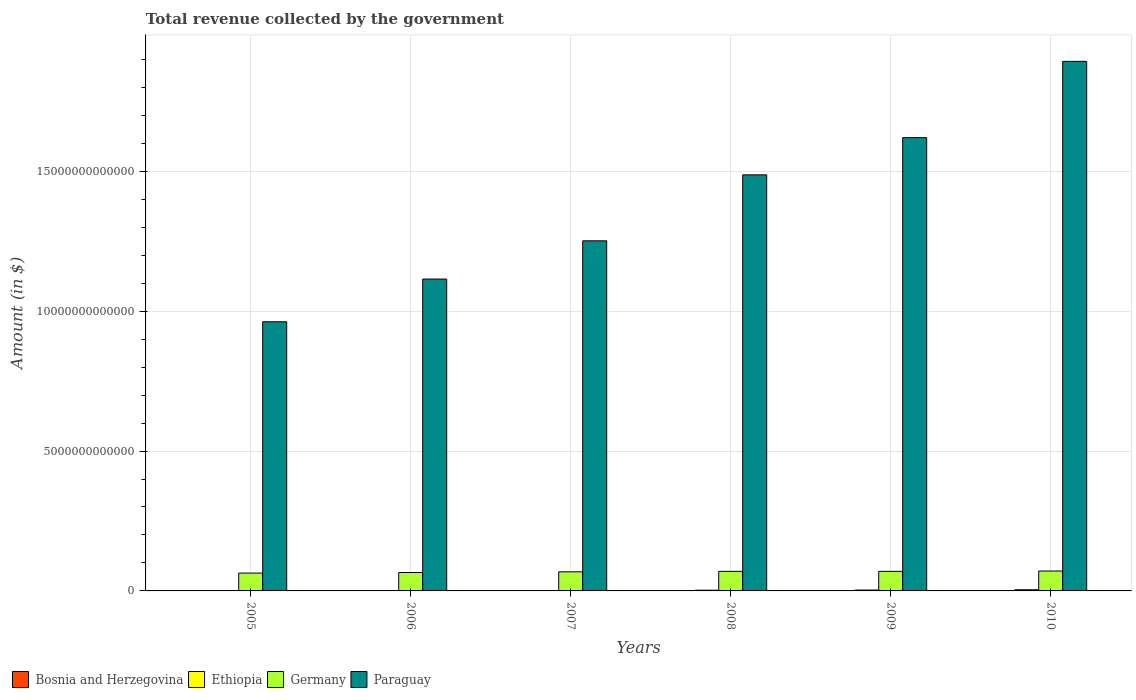How many different coloured bars are there?
Your answer should be compact. 4. Are the number of bars per tick equal to the number of legend labels?
Provide a succinct answer. Yes. How many bars are there on the 4th tick from the left?
Offer a very short reply. 4. What is the total revenue collected by the government in Ethiopia in 2008?
Your response must be concise. 2.54e+1. Across all years, what is the maximum total revenue collected by the government in Ethiopia?
Provide a succinct answer. 4.15e+1. Across all years, what is the minimum total revenue collected by the government in Paraguay?
Your answer should be compact. 9.62e+12. In which year was the total revenue collected by the government in Bosnia and Herzegovina minimum?
Provide a short and direct response. 2005. What is the total total revenue collected by the government in Ethiopia in the graph?
Offer a very short reply. 1.37e+11. What is the difference between the total revenue collected by the government in Paraguay in 2005 and that in 2009?
Keep it short and to the point. -6.58e+12. What is the difference between the total revenue collected by the government in Ethiopia in 2007 and the total revenue collected by the government in Paraguay in 2006?
Your answer should be compact. -1.11e+13. What is the average total revenue collected by the government in Paraguay per year?
Provide a short and direct response. 1.39e+13. In the year 2010, what is the difference between the total revenue collected by the government in Germany and total revenue collected by the government in Paraguay?
Make the answer very short. -1.82e+13. What is the ratio of the total revenue collected by the government in Germany in 2005 to that in 2010?
Give a very brief answer. 0.9. Is the difference between the total revenue collected by the government in Germany in 2009 and 2010 greater than the difference between the total revenue collected by the government in Paraguay in 2009 and 2010?
Provide a short and direct response. Yes. What is the difference between the highest and the second highest total revenue collected by the government in Bosnia and Herzegovina?
Give a very brief answer. 6.63e+07. What is the difference between the highest and the lowest total revenue collected by the government in Bosnia and Herzegovina?
Your response must be concise. 3.46e+09. In how many years, is the total revenue collected by the government in Paraguay greater than the average total revenue collected by the government in Paraguay taken over all years?
Provide a succinct answer. 3. Is the sum of the total revenue collected by the government in Germany in 2007 and 2010 greater than the maximum total revenue collected by the government in Paraguay across all years?
Provide a succinct answer. No. What does the 1st bar from the left in 2005 represents?
Ensure brevity in your answer.  Bosnia and Herzegovina. What does the 1st bar from the right in 2008 represents?
Make the answer very short. Paraguay. Are all the bars in the graph horizontal?
Give a very brief answer. No. How many years are there in the graph?
Your response must be concise. 6. What is the difference between two consecutive major ticks on the Y-axis?
Give a very brief answer. 5.00e+12. Are the values on the major ticks of Y-axis written in scientific E-notation?
Ensure brevity in your answer.  No. Does the graph contain any zero values?
Keep it short and to the point. No. Does the graph contain grids?
Offer a very short reply. Yes. Where does the legend appear in the graph?
Offer a very short reply. Bottom left. What is the title of the graph?
Keep it short and to the point. Total revenue collected by the government. What is the label or title of the Y-axis?
Your answer should be compact. Amount (in $). What is the Amount (in $) in Bosnia and Herzegovina in 2005?
Provide a short and direct response. 6.27e+09. What is the Amount (in $) in Ethiopia in 2005?
Your answer should be compact. 1.17e+1. What is the Amount (in $) of Germany in 2005?
Make the answer very short. 6.37e+11. What is the Amount (in $) of Paraguay in 2005?
Provide a succinct answer. 9.62e+12. What is the Amount (in $) of Bosnia and Herzegovina in 2006?
Your answer should be compact. 7.62e+09. What is the Amount (in $) of Ethiopia in 2006?
Make the answer very short. 1.18e+1. What is the Amount (in $) of Germany in 2006?
Your response must be concise. 6.58e+11. What is the Amount (in $) of Paraguay in 2006?
Give a very brief answer. 1.11e+13. What is the Amount (in $) of Bosnia and Herzegovina in 2007?
Your response must be concise. 8.71e+09. What is the Amount (in $) in Ethiopia in 2007?
Your answer should be compact. 1.43e+1. What is the Amount (in $) of Germany in 2007?
Make the answer very short. 6.83e+11. What is the Amount (in $) in Paraguay in 2007?
Offer a terse response. 1.25e+13. What is the Amount (in $) of Bosnia and Herzegovina in 2008?
Keep it short and to the point. 9.67e+09. What is the Amount (in $) in Ethiopia in 2008?
Offer a very short reply. 2.54e+1. What is the Amount (in $) of Germany in 2008?
Give a very brief answer. 6.99e+11. What is the Amount (in $) of Paraguay in 2008?
Offer a very short reply. 1.49e+13. What is the Amount (in $) of Bosnia and Herzegovina in 2009?
Ensure brevity in your answer.  9.26e+09. What is the Amount (in $) in Ethiopia in 2009?
Your response must be concise. 3.18e+1. What is the Amount (in $) of Germany in 2009?
Offer a terse response. 7.00e+11. What is the Amount (in $) in Paraguay in 2009?
Your response must be concise. 1.62e+13. What is the Amount (in $) in Bosnia and Herzegovina in 2010?
Ensure brevity in your answer.  9.73e+09. What is the Amount (in $) of Ethiopia in 2010?
Ensure brevity in your answer.  4.15e+1. What is the Amount (in $) of Germany in 2010?
Provide a succinct answer. 7.12e+11. What is the Amount (in $) of Paraguay in 2010?
Your response must be concise. 1.89e+13. Across all years, what is the maximum Amount (in $) in Bosnia and Herzegovina?
Keep it short and to the point. 9.73e+09. Across all years, what is the maximum Amount (in $) of Ethiopia?
Your response must be concise. 4.15e+1. Across all years, what is the maximum Amount (in $) of Germany?
Make the answer very short. 7.12e+11. Across all years, what is the maximum Amount (in $) of Paraguay?
Provide a succinct answer. 1.89e+13. Across all years, what is the minimum Amount (in $) of Bosnia and Herzegovina?
Keep it short and to the point. 6.27e+09. Across all years, what is the minimum Amount (in $) of Ethiopia?
Your response must be concise. 1.17e+1. Across all years, what is the minimum Amount (in $) in Germany?
Provide a short and direct response. 6.37e+11. Across all years, what is the minimum Amount (in $) in Paraguay?
Provide a short and direct response. 9.62e+12. What is the total Amount (in $) in Bosnia and Herzegovina in the graph?
Provide a succinct answer. 5.13e+1. What is the total Amount (in $) of Ethiopia in the graph?
Offer a very short reply. 1.37e+11. What is the total Amount (in $) of Germany in the graph?
Keep it short and to the point. 4.09e+12. What is the total Amount (in $) in Paraguay in the graph?
Make the answer very short. 8.33e+13. What is the difference between the Amount (in $) in Bosnia and Herzegovina in 2005 and that in 2006?
Give a very brief answer. -1.36e+09. What is the difference between the Amount (in $) of Ethiopia in 2005 and that in 2006?
Offer a terse response. -3.44e+07. What is the difference between the Amount (in $) of Germany in 2005 and that in 2006?
Give a very brief answer. -2.10e+1. What is the difference between the Amount (in $) in Paraguay in 2005 and that in 2006?
Give a very brief answer. -1.53e+12. What is the difference between the Amount (in $) of Bosnia and Herzegovina in 2005 and that in 2007?
Your answer should be compact. -2.44e+09. What is the difference between the Amount (in $) of Ethiopia in 2005 and that in 2007?
Your answer should be compact. -2.59e+09. What is the difference between the Amount (in $) of Germany in 2005 and that in 2007?
Offer a terse response. -4.54e+1. What is the difference between the Amount (in $) of Paraguay in 2005 and that in 2007?
Offer a terse response. -2.89e+12. What is the difference between the Amount (in $) of Bosnia and Herzegovina in 2005 and that in 2008?
Offer a very short reply. -3.40e+09. What is the difference between the Amount (in $) in Ethiopia in 2005 and that in 2008?
Ensure brevity in your answer.  -1.36e+1. What is the difference between the Amount (in $) of Germany in 2005 and that in 2008?
Your response must be concise. -6.20e+1. What is the difference between the Amount (in $) of Paraguay in 2005 and that in 2008?
Your answer should be very brief. -5.25e+12. What is the difference between the Amount (in $) of Bosnia and Herzegovina in 2005 and that in 2009?
Give a very brief answer. -3.00e+09. What is the difference between the Amount (in $) of Ethiopia in 2005 and that in 2009?
Your answer should be very brief. -2.00e+1. What is the difference between the Amount (in $) in Germany in 2005 and that in 2009?
Keep it short and to the point. -6.23e+1. What is the difference between the Amount (in $) of Paraguay in 2005 and that in 2009?
Provide a succinct answer. -6.58e+12. What is the difference between the Amount (in $) of Bosnia and Herzegovina in 2005 and that in 2010?
Offer a terse response. -3.46e+09. What is the difference between the Amount (in $) in Ethiopia in 2005 and that in 2010?
Make the answer very short. -2.98e+1. What is the difference between the Amount (in $) of Germany in 2005 and that in 2010?
Offer a terse response. -7.46e+1. What is the difference between the Amount (in $) in Paraguay in 2005 and that in 2010?
Make the answer very short. -9.31e+12. What is the difference between the Amount (in $) in Bosnia and Herzegovina in 2006 and that in 2007?
Ensure brevity in your answer.  -1.09e+09. What is the difference between the Amount (in $) of Ethiopia in 2006 and that in 2007?
Provide a succinct answer. -2.56e+09. What is the difference between the Amount (in $) of Germany in 2006 and that in 2007?
Keep it short and to the point. -2.44e+1. What is the difference between the Amount (in $) in Paraguay in 2006 and that in 2007?
Offer a terse response. -1.37e+12. What is the difference between the Amount (in $) in Bosnia and Herzegovina in 2006 and that in 2008?
Give a very brief answer. -2.04e+09. What is the difference between the Amount (in $) of Ethiopia in 2006 and that in 2008?
Give a very brief answer. -1.36e+1. What is the difference between the Amount (in $) of Germany in 2006 and that in 2008?
Your response must be concise. -4.10e+1. What is the difference between the Amount (in $) in Paraguay in 2006 and that in 2008?
Offer a very short reply. -3.73e+12. What is the difference between the Amount (in $) of Bosnia and Herzegovina in 2006 and that in 2009?
Your response must be concise. -1.64e+09. What is the difference between the Amount (in $) of Ethiopia in 2006 and that in 2009?
Provide a succinct answer. -2.00e+1. What is the difference between the Amount (in $) in Germany in 2006 and that in 2009?
Offer a terse response. -4.14e+1. What is the difference between the Amount (in $) in Paraguay in 2006 and that in 2009?
Your response must be concise. -5.06e+12. What is the difference between the Amount (in $) of Bosnia and Herzegovina in 2006 and that in 2010?
Keep it short and to the point. -2.11e+09. What is the difference between the Amount (in $) in Ethiopia in 2006 and that in 2010?
Your response must be concise. -2.98e+1. What is the difference between the Amount (in $) of Germany in 2006 and that in 2010?
Ensure brevity in your answer.  -5.36e+1. What is the difference between the Amount (in $) of Paraguay in 2006 and that in 2010?
Offer a very short reply. -7.78e+12. What is the difference between the Amount (in $) of Bosnia and Herzegovina in 2007 and that in 2008?
Your response must be concise. -9.56e+08. What is the difference between the Amount (in $) in Ethiopia in 2007 and that in 2008?
Your answer should be compact. -1.11e+1. What is the difference between the Amount (in $) in Germany in 2007 and that in 2008?
Keep it short and to the point. -1.66e+1. What is the difference between the Amount (in $) in Paraguay in 2007 and that in 2008?
Keep it short and to the point. -2.36e+12. What is the difference between the Amount (in $) in Bosnia and Herzegovina in 2007 and that in 2009?
Keep it short and to the point. -5.53e+08. What is the difference between the Amount (in $) of Ethiopia in 2007 and that in 2009?
Provide a succinct answer. -1.74e+1. What is the difference between the Amount (in $) in Germany in 2007 and that in 2009?
Provide a succinct answer. -1.69e+1. What is the difference between the Amount (in $) of Paraguay in 2007 and that in 2009?
Your response must be concise. -3.69e+12. What is the difference between the Amount (in $) of Bosnia and Herzegovina in 2007 and that in 2010?
Your answer should be very brief. -1.02e+09. What is the difference between the Amount (in $) of Ethiopia in 2007 and that in 2010?
Offer a terse response. -2.72e+1. What is the difference between the Amount (in $) in Germany in 2007 and that in 2010?
Make the answer very short. -2.92e+1. What is the difference between the Amount (in $) of Paraguay in 2007 and that in 2010?
Your answer should be compact. -6.41e+12. What is the difference between the Amount (in $) of Bosnia and Herzegovina in 2008 and that in 2009?
Provide a short and direct response. 4.02e+08. What is the difference between the Amount (in $) in Ethiopia in 2008 and that in 2009?
Offer a very short reply. -6.40e+09. What is the difference between the Amount (in $) of Germany in 2008 and that in 2009?
Keep it short and to the point. -3.50e+08. What is the difference between the Amount (in $) of Paraguay in 2008 and that in 2009?
Provide a succinct answer. -1.33e+12. What is the difference between the Amount (in $) of Bosnia and Herzegovina in 2008 and that in 2010?
Make the answer very short. -6.63e+07. What is the difference between the Amount (in $) of Ethiopia in 2008 and that in 2010?
Your answer should be compact. -1.61e+1. What is the difference between the Amount (in $) of Germany in 2008 and that in 2010?
Keep it short and to the point. -1.26e+1. What is the difference between the Amount (in $) in Paraguay in 2008 and that in 2010?
Your response must be concise. -4.06e+12. What is the difference between the Amount (in $) in Bosnia and Herzegovina in 2009 and that in 2010?
Your response must be concise. -4.68e+08. What is the difference between the Amount (in $) in Ethiopia in 2009 and that in 2010?
Provide a short and direct response. -9.75e+09. What is the difference between the Amount (in $) of Germany in 2009 and that in 2010?
Make the answer very short. -1.23e+1. What is the difference between the Amount (in $) in Paraguay in 2009 and that in 2010?
Offer a terse response. -2.73e+12. What is the difference between the Amount (in $) in Bosnia and Herzegovina in 2005 and the Amount (in $) in Ethiopia in 2006?
Make the answer very short. -5.50e+09. What is the difference between the Amount (in $) of Bosnia and Herzegovina in 2005 and the Amount (in $) of Germany in 2006?
Your response must be concise. -6.52e+11. What is the difference between the Amount (in $) in Bosnia and Herzegovina in 2005 and the Amount (in $) in Paraguay in 2006?
Give a very brief answer. -1.11e+13. What is the difference between the Amount (in $) of Ethiopia in 2005 and the Amount (in $) of Germany in 2006?
Offer a terse response. -6.46e+11. What is the difference between the Amount (in $) in Ethiopia in 2005 and the Amount (in $) in Paraguay in 2006?
Make the answer very short. -1.11e+13. What is the difference between the Amount (in $) of Germany in 2005 and the Amount (in $) of Paraguay in 2006?
Provide a short and direct response. -1.05e+13. What is the difference between the Amount (in $) of Bosnia and Herzegovina in 2005 and the Amount (in $) of Ethiopia in 2007?
Make the answer very short. -8.06e+09. What is the difference between the Amount (in $) in Bosnia and Herzegovina in 2005 and the Amount (in $) in Germany in 2007?
Your answer should be very brief. -6.76e+11. What is the difference between the Amount (in $) in Bosnia and Herzegovina in 2005 and the Amount (in $) in Paraguay in 2007?
Ensure brevity in your answer.  -1.25e+13. What is the difference between the Amount (in $) in Ethiopia in 2005 and the Amount (in $) in Germany in 2007?
Make the answer very short. -6.71e+11. What is the difference between the Amount (in $) of Ethiopia in 2005 and the Amount (in $) of Paraguay in 2007?
Ensure brevity in your answer.  -1.25e+13. What is the difference between the Amount (in $) in Germany in 2005 and the Amount (in $) in Paraguay in 2007?
Keep it short and to the point. -1.19e+13. What is the difference between the Amount (in $) in Bosnia and Herzegovina in 2005 and the Amount (in $) in Ethiopia in 2008?
Ensure brevity in your answer.  -1.91e+1. What is the difference between the Amount (in $) in Bosnia and Herzegovina in 2005 and the Amount (in $) in Germany in 2008?
Your answer should be very brief. -6.93e+11. What is the difference between the Amount (in $) in Bosnia and Herzegovina in 2005 and the Amount (in $) in Paraguay in 2008?
Provide a short and direct response. -1.49e+13. What is the difference between the Amount (in $) in Ethiopia in 2005 and the Amount (in $) in Germany in 2008?
Your answer should be compact. -6.88e+11. What is the difference between the Amount (in $) of Ethiopia in 2005 and the Amount (in $) of Paraguay in 2008?
Make the answer very short. -1.49e+13. What is the difference between the Amount (in $) in Germany in 2005 and the Amount (in $) in Paraguay in 2008?
Your response must be concise. -1.42e+13. What is the difference between the Amount (in $) in Bosnia and Herzegovina in 2005 and the Amount (in $) in Ethiopia in 2009?
Keep it short and to the point. -2.55e+1. What is the difference between the Amount (in $) in Bosnia and Herzegovina in 2005 and the Amount (in $) in Germany in 2009?
Give a very brief answer. -6.93e+11. What is the difference between the Amount (in $) in Bosnia and Herzegovina in 2005 and the Amount (in $) in Paraguay in 2009?
Your answer should be very brief. -1.62e+13. What is the difference between the Amount (in $) of Ethiopia in 2005 and the Amount (in $) of Germany in 2009?
Provide a short and direct response. -6.88e+11. What is the difference between the Amount (in $) in Ethiopia in 2005 and the Amount (in $) in Paraguay in 2009?
Give a very brief answer. -1.62e+13. What is the difference between the Amount (in $) in Germany in 2005 and the Amount (in $) in Paraguay in 2009?
Make the answer very short. -1.56e+13. What is the difference between the Amount (in $) in Bosnia and Herzegovina in 2005 and the Amount (in $) in Ethiopia in 2010?
Offer a very short reply. -3.53e+1. What is the difference between the Amount (in $) of Bosnia and Herzegovina in 2005 and the Amount (in $) of Germany in 2010?
Make the answer very short. -7.06e+11. What is the difference between the Amount (in $) in Bosnia and Herzegovina in 2005 and the Amount (in $) in Paraguay in 2010?
Offer a terse response. -1.89e+13. What is the difference between the Amount (in $) in Ethiopia in 2005 and the Amount (in $) in Germany in 2010?
Your answer should be very brief. -7.00e+11. What is the difference between the Amount (in $) of Ethiopia in 2005 and the Amount (in $) of Paraguay in 2010?
Make the answer very short. -1.89e+13. What is the difference between the Amount (in $) in Germany in 2005 and the Amount (in $) in Paraguay in 2010?
Provide a short and direct response. -1.83e+13. What is the difference between the Amount (in $) in Bosnia and Herzegovina in 2006 and the Amount (in $) in Ethiopia in 2007?
Provide a succinct answer. -6.70e+09. What is the difference between the Amount (in $) in Bosnia and Herzegovina in 2006 and the Amount (in $) in Germany in 2007?
Keep it short and to the point. -6.75e+11. What is the difference between the Amount (in $) in Bosnia and Herzegovina in 2006 and the Amount (in $) in Paraguay in 2007?
Ensure brevity in your answer.  -1.25e+13. What is the difference between the Amount (in $) in Ethiopia in 2006 and the Amount (in $) in Germany in 2007?
Offer a very short reply. -6.71e+11. What is the difference between the Amount (in $) of Ethiopia in 2006 and the Amount (in $) of Paraguay in 2007?
Your answer should be very brief. -1.25e+13. What is the difference between the Amount (in $) in Germany in 2006 and the Amount (in $) in Paraguay in 2007?
Give a very brief answer. -1.19e+13. What is the difference between the Amount (in $) in Bosnia and Herzegovina in 2006 and the Amount (in $) in Ethiopia in 2008?
Make the answer very short. -1.78e+1. What is the difference between the Amount (in $) of Bosnia and Herzegovina in 2006 and the Amount (in $) of Germany in 2008?
Keep it short and to the point. -6.92e+11. What is the difference between the Amount (in $) of Bosnia and Herzegovina in 2006 and the Amount (in $) of Paraguay in 2008?
Your answer should be compact. -1.49e+13. What is the difference between the Amount (in $) of Ethiopia in 2006 and the Amount (in $) of Germany in 2008?
Make the answer very short. -6.87e+11. What is the difference between the Amount (in $) in Ethiopia in 2006 and the Amount (in $) in Paraguay in 2008?
Your answer should be very brief. -1.49e+13. What is the difference between the Amount (in $) of Germany in 2006 and the Amount (in $) of Paraguay in 2008?
Keep it short and to the point. -1.42e+13. What is the difference between the Amount (in $) in Bosnia and Herzegovina in 2006 and the Amount (in $) in Ethiopia in 2009?
Provide a short and direct response. -2.42e+1. What is the difference between the Amount (in $) of Bosnia and Herzegovina in 2006 and the Amount (in $) of Germany in 2009?
Offer a very short reply. -6.92e+11. What is the difference between the Amount (in $) of Bosnia and Herzegovina in 2006 and the Amount (in $) of Paraguay in 2009?
Your answer should be very brief. -1.62e+13. What is the difference between the Amount (in $) of Ethiopia in 2006 and the Amount (in $) of Germany in 2009?
Your response must be concise. -6.88e+11. What is the difference between the Amount (in $) of Ethiopia in 2006 and the Amount (in $) of Paraguay in 2009?
Ensure brevity in your answer.  -1.62e+13. What is the difference between the Amount (in $) in Germany in 2006 and the Amount (in $) in Paraguay in 2009?
Provide a short and direct response. -1.55e+13. What is the difference between the Amount (in $) of Bosnia and Herzegovina in 2006 and the Amount (in $) of Ethiopia in 2010?
Your answer should be compact. -3.39e+1. What is the difference between the Amount (in $) of Bosnia and Herzegovina in 2006 and the Amount (in $) of Germany in 2010?
Offer a very short reply. -7.04e+11. What is the difference between the Amount (in $) of Bosnia and Herzegovina in 2006 and the Amount (in $) of Paraguay in 2010?
Keep it short and to the point. -1.89e+13. What is the difference between the Amount (in $) in Ethiopia in 2006 and the Amount (in $) in Germany in 2010?
Give a very brief answer. -7.00e+11. What is the difference between the Amount (in $) of Ethiopia in 2006 and the Amount (in $) of Paraguay in 2010?
Ensure brevity in your answer.  -1.89e+13. What is the difference between the Amount (in $) of Germany in 2006 and the Amount (in $) of Paraguay in 2010?
Provide a succinct answer. -1.83e+13. What is the difference between the Amount (in $) of Bosnia and Herzegovina in 2007 and the Amount (in $) of Ethiopia in 2008?
Your answer should be very brief. -1.67e+1. What is the difference between the Amount (in $) in Bosnia and Herzegovina in 2007 and the Amount (in $) in Germany in 2008?
Your answer should be compact. -6.91e+11. What is the difference between the Amount (in $) of Bosnia and Herzegovina in 2007 and the Amount (in $) of Paraguay in 2008?
Make the answer very short. -1.49e+13. What is the difference between the Amount (in $) of Ethiopia in 2007 and the Amount (in $) of Germany in 2008?
Provide a succinct answer. -6.85e+11. What is the difference between the Amount (in $) in Ethiopia in 2007 and the Amount (in $) in Paraguay in 2008?
Provide a short and direct response. -1.49e+13. What is the difference between the Amount (in $) in Germany in 2007 and the Amount (in $) in Paraguay in 2008?
Provide a short and direct response. -1.42e+13. What is the difference between the Amount (in $) in Bosnia and Herzegovina in 2007 and the Amount (in $) in Ethiopia in 2009?
Provide a short and direct response. -2.31e+1. What is the difference between the Amount (in $) of Bosnia and Herzegovina in 2007 and the Amount (in $) of Germany in 2009?
Ensure brevity in your answer.  -6.91e+11. What is the difference between the Amount (in $) of Bosnia and Herzegovina in 2007 and the Amount (in $) of Paraguay in 2009?
Your answer should be very brief. -1.62e+13. What is the difference between the Amount (in $) of Ethiopia in 2007 and the Amount (in $) of Germany in 2009?
Keep it short and to the point. -6.85e+11. What is the difference between the Amount (in $) in Ethiopia in 2007 and the Amount (in $) in Paraguay in 2009?
Your answer should be very brief. -1.62e+13. What is the difference between the Amount (in $) of Germany in 2007 and the Amount (in $) of Paraguay in 2009?
Keep it short and to the point. -1.55e+13. What is the difference between the Amount (in $) in Bosnia and Herzegovina in 2007 and the Amount (in $) in Ethiopia in 2010?
Give a very brief answer. -3.28e+1. What is the difference between the Amount (in $) of Bosnia and Herzegovina in 2007 and the Amount (in $) of Germany in 2010?
Provide a short and direct response. -7.03e+11. What is the difference between the Amount (in $) of Bosnia and Herzegovina in 2007 and the Amount (in $) of Paraguay in 2010?
Offer a terse response. -1.89e+13. What is the difference between the Amount (in $) in Ethiopia in 2007 and the Amount (in $) in Germany in 2010?
Your answer should be compact. -6.98e+11. What is the difference between the Amount (in $) of Ethiopia in 2007 and the Amount (in $) of Paraguay in 2010?
Your answer should be compact. -1.89e+13. What is the difference between the Amount (in $) in Germany in 2007 and the Amount (in $) in Paraguay in 2010?
Your response must be concise. -1.82e+13. What is the difference between the Amount (in $) in Bosnia and Herzegovina in 2008 and the Amount (in $) in Ethiopia in 2009?
Your response must be concise. -2.21e+1. What is the difference between the Amount (in $) of Bosnia and Herzegovina in 2008 and the Amount (in $) of Germany in 2009?
Your answer should be compact. -6.90e+11. What is the difference between the Amount (in $) in Bosnia and Herzegovina in 2008 and the Amount (in $) in Paraguay in 2009?
Provide a succinct answer. -1.62e+13. What is the difference between the Amount (in $) in Ethiopia in 2008 and the Amount (in $) in Germany in 2009?
Ensure brevity in your answer.  -6.74e+11. What is the difference between the Amount (in $) of Ethiopia in 2008 and the Amount (in $) of Paraguay in 2009?
Provide a succinct answer. -1.62e+13. What is the difference between the Amount (in $) of Germany in 2008 and the Amount (in $) of Paraguay in 2009?
Make the answer very short. -1.55e+13. What is the difference between the Amount (in $) in Bosnia and Herzegovina in 2008 and the Amount (in $) in Ethiopia in 2010?
Provide a short and direct response. -3.19e+1. What is the difference between the Amount (in $) in Bosnia and Herzegovina in 2008 and the Amount (in $) in Germany in 2010?
Provide a succinct answer. -7.02e+11. What is the difference between the Amount (in $) in Bosnia and Herzegovina in 2008 and the Amount (in $) in Paraguay in 2010?
Your response must be concise. -1.89e+13. What is the difference between the Amount (in $) in Ethiopia in 2008 and the Amount (in $) in Germany in 2010?
Make the answer very short. -6.86e+11. What is the difference between the Amount (in $) in Ethiopia in 2008 and the Amount (in $) in Paraguay in 2010?
Your answer should be very brief. -1.89e+13. What is the difference between the Amount (in $) in Germany in 2008 and the Amount (in $) in Paraguay in 2010?
Provide a short and direct response. -1.82e+13. What is the difference between the Amount (in $) in Bosnia and Herzegovina in 2009 and the Amount (in $) in Ethiopia in 2010?
Offer a very short reply. -3.23e+1. What is the difference between the Amount (in $) of Bosnia and Herzegovina in 2009 and the Amount (in $) of Germany in 2010?
Provide a succinct answer. -7.03e+11. What is the difference between the Amount (in $) of Bosnia and Herzegovina in 2009 and the Amount (in $) of Paraguay in 2010?
Offer a very short reply. -1.89e+13. What is the difference between the Amount (in $) in Ethiopia in 2009 and the Amount (in $) in Germany in 2010?
Make the answer very short. -6.80e+11. What is the difference between the Amount (in $) in Ethiopia in 2009 and the Amount (in $) in Paraguay in 2010?
Your answer should be compact. -1.89e+13. What is the difference between the Amount (in $) in Germany in 2009 and the Amount (in $) in Paraguay in 2010?
Make the answer very short. -1.82e+13. What is the average Amount (in $) in Bosnia and Herzegovina per year?
Ensure brevity in your answer.  8.54e+09. What is the average Amount (in $) of Ethiopia per year?
Ensure brevity in your answer.  2.28e+1. What is the average Amount (in $) of Germany per year?
Your answer should be compact. 6.81e+11. What is the average Amount (in $) of Paraguay per year?
Your answer should be compact. 1.39e+13. In the year 2005, what is the difference between the Amount (in $) of Bosnia and Herzegovina and Amount (in $) of Ethiopia?
Ensure brevity in your answer.  -5.47e+09. In the year 2005, what is the difference between the Amount (in $) in Bosnia and Herzegovina and Amount (in $) in Germany?
Ensure brevity in your answer.  -6.31e+11. In the year 2005, what is the difference between the Amount (in $) in Bosnia and Herzegovina and Amount (in $) in Paraguay?
Your answer should be compact. -9.61e+12. In the year 2005, what is the difference between the Amount (in $) in Ethiopia and Amount (in $) in Germany?
Your answer should be compact. -6.26e+11. In the year 2005, what is the difference between the Amount (in $) in Ethiopia and Amount (in $) in Paraguay?
Ensure brevity in your answer.  -9.61e+12. In the year 2005, what is the difference between the Amount (in $) of Germany and Amount (in $) of Paraguay?
Your answer should be compact. -8.98e+12. In the year 2006, what is the difference between the Amount (in $) in Bosnia and Herzegovina and Amount (in $) in Ethiopia?
Your answer should be very brief. -4.14e+09. In the year 2006, what is the difference between the Amount (in $) of Bosnia and Herzegovina and Amount (in $) of Germany?
Provide a short and direct response. -6.51e+11. In the year 2006, what is the difference between the Amount (in $) in Bosnia and Herzegovina and Amount (in $) in Paraguay?
Make the answer very short. -1.11e+13. In the year 2006, what is the difference between the Amount (in $) in Ethiopia and Amount (in $) in Germany?
Your answer should be compact. -6.46e+11. In the year 2006, what is the difference between the Amount (in $) in Ethiopia and Amount (in $) in Paraguay?
Offer a terse response. -1.11e+13. In the year 2006, what is the difference between the Amount (in $) in Germany and Amount (in $) in Paraguay?
Offer a terse response. -1.05e+13. In the year 2007, what is the difference between the Amount (in $) in Bosnia and Herzegovina and Amount (in $) in Ethiopia?
Make the answer very short. -5.62e+09. In the year 2007, what is the difference between the Amount (in $) in Bosnia and Herzegovina and Amount (in $) in Germany?
Make the answer very short. -6.74e+11. In the year 2007, what is the difference between the Amount (in $) of Bosnia and Herzegovina and Amount (in $) of Paraguay?
Keep it short and to the point. -1.25e+13. In the year 2007, what is the difference between the Amount (in $) of Ethiopia and Amount (in $) of Germany?
Give a very brief answer. -6.68e+11. In the year 2007, what is the difference between the Amount (in $) of Ethiopia and Amount (in $) of Paraguay?
Give a very brief answer. -1.25e+13. In the year 2007, what is the difference between the Amount (in $) of Germany and Amount (in $) of Paraguay?
Make the answer very short. -1.18e+13. In the year 2008, what is the difference between the Amount (in $) of Bosnia and Herzegovina and Amount (in $) of Ethiopia?
Keep it short and to the point. -1.57e+1. In the year 2008, what is the difference between the Amount (in $) in Bosnia and Herzegovina and Amount (in $) in Germany?
Your response must be concise. -6.90e+11. In the year 2008, what is the difference between the Amount (in $) of Bosnia and Herzegovina and Amount (in $) of Paraguay?
Your answer should be compact. -1.49e+13. In the year 2008, what is the difference between the Amount (in $) of Ethiopia and Amount (in $) of Germany?
Ensure brevity in your answer.  -6.74e+11. In the year 2008, what is the difference between the Amount (in $) in Ethiopia and Amount (in $) in Paraguay?
Offer a very short reply. -1.48e+13. In the year 2008, what is the difference between the Amount (in $) of Germany and Amount (in $) of Paraguay?
Your response must be concise. -1.42e+13. In the year 2009, what is the difference between the Amount (in $) in Bosnia and Herzegovina and Amount (in $) in Ethiopia?
Provide a short and direct response. -2.25e+1. In the year 2009, what is the difference between the Amount (in $) in Bosnia and Herzegovina and Amount (in $) in Germany?
Provide a succinct answer. -6.90e+11. In the year 2009, what is the difference between the Amount (in $) of Bosnia and Herzegovina and Amount (in $) of Paraguay?
Offer a terse response. -1.62e+13. In the year 2009, what is the difference between the Amount (in $) of Ethiopia and Amount (in $) of Germany?
Ensure brevity in your answer.  -6.68e+11. In the year 2009, what is the difference between the Amount (in $) in Ethiopia and Amount (in $) in Paraguay?
Your answer should be very brief. -1.62e+13. In the year 2009, what is the difference between the Amount (in $) of Germany and Amount (in $) of Paraguay?
Provide a succinct answer. -1.55e+13. In the year 2010, what is the difference between the Amount (in $) of Bosnia and Herzegovina and Amount (in $) of Ethiopia?
Make the answer very short. -3.18e+1. In the year 2010, what is the difference between the Amount (in $) in Bosnia and Herzegovina and Amount (in $) in Germany?
Your answer should be compact. -7.02e+11. In the year 2010, what is the difference between the Amount (in $) in Bosnia and Herzegovina and Amount (in $) in Paraguay?
Make the answer very short. -1.89e+13. In the year 2010, what is the difference between the Amount (in $) in Ethiopia and Amount (in $) in Germany?
Provide a succinct answer. -6.70e+11. In the year 2010, what is the difference between the Amount (in $) of Ethiopia and Amount (in $) of Paraguay?
Provide a succinct answer. -1.89e+13. In the year 2010, what is the difference between the Amount (in $) in Germany and Amount (in $) in Paraguay?
Give a very brief answer. -1.82e+13. What is the ratio of the Amount (in $) in Bosnia and Herzegovina in 2005 to that in 2006?
Your answer should be compact. 0.82. What is the ratio of the Amount (in $) in Germany in 2005 to that in 2006?
Ensure brevity in your answer.  0.97. What is the ratio of the Amount (in $) of Paraguay in 2005 to that in 2006?
Keep it short and to the point. 0.86. What is the ratio of the Amount (in $) of Bosnia and Herzegovina in 2005 to that in 2007?
Offer a terse response. 0.72. What is the ratio of the Amount (in $) in Ethiopia in 2005 to that in 2007?
Provide a short and direct response. 0.82. What is the ratio of the Amount (in $) of Germany in 2005 to that in 2007?
Give a very brief answer. 0.93. What is the ratio of the Amount (in $) in Paraguay in 2005 to that in 2007?
Give a very brief answer. 0.77. What is the ratio of the Amount (in $) in Bosnia and Herzegovina in 2005 to that in 2008?
Your answer should be compact. 0.65. What is the ratio of the Amount (in $) in Ethiopia in 2005 to that in 2008?
Ensure brevity in your answer.  0.46. What is the ratio of the Amount (in $) in Germany in 2005 to that in 2008?
Your response must be concise. 0.91. What is the ratio of the Amount (in $) of Paraguay in 2005 to that in 2008?
Your answer should be very brief. 0.65. What is the ratio of the Amount (in $) of Bosnia and Herzegovina in 2005 to that in 2009?
Ensure brevity in your answer.  0.68. What is the ratio of the Amount (in $) in Ethiopia in 2005 to that in 2009?
Your response must be concise. 0.37. What is the ratio of the Amount (in $) in Germany in 2005 to that in 2009?
Offer a terse response. 0.91. What is the ratio of the Amount (in $) of Paraguay in 2005 to that in 2009?
Your answer should be compact. 0.59. What is the ratio of the Amount (in $) in Bosnia and Herzegovina in 2005 to that in 2010?
Make the answer very short. 0.64. What is the ratio of the Amount (in $) in Ethiopia in 2005 to that in 2010?
Offer a very short reply. 0.28. What is the ratio of the Amount (in $) of Germany in 2005 to that in 2010?
Keep it short and to the point. 0.9. What is the ratio of the Amount (in $) in Paraguay in 2005 to that in 2010?
Your response must be concise. 0.51. What is the ratio of the Amount (in $) in Bosnia and Herzegovina in 2006 to that in 2007?
Give a very brief answer. 0.88. What is the ratio of the Amount (in $) of Ethiopia in 2006 to that in 2007?
Your answer should be compact. 0.82. What is the ratio of the Amount (in $) of Germany in 2006 to that in 2007?
Offer a very short reply. 0.96. What is the ratio of the Amount (in $) of Paraguay in 2006 to that in 2007?
Make the answer very short. 0.89. What is the ratio of the Amount (in $) in Bosnia and Herzegovina in 2006 to that in 2008?
Provide a succinct answer. 0.79. What is the ratio of the Amount (in $) in Ethiopia in 2006 to that in 2008?
Offer a terse response. 0.46. What is the ratio of the Amount (in $) in Germany in 2006 to that in 2008?
Offer a very short reply. 0.94. What is the ratio of the Amount (in $) in Paraguay in 2006 to that in 2008?
Keep it short and to the point. 0.75. What is the ratio of the Amount (in $) of Bosnia and Herzegovina in 2006 to that in 2009?
Make the answer very short. 0.82. What is the ratio of the Amount (in $) of Ethiopia in 2006 to that in 2009?
Your answer should be compact. 0.37. What is the ratio of the Amount (in $) of Germany in 2006 to that in 2009?
Offer a very short reply. 0.94. What is the ratio of the Amount (in $) in Paraguay in 2006 to that in 2009?
Your answer should be compact. 0.69. What is the ratio of the Amount (in $) of Bosnia and Herzegovina in 2006 to that in 2010?
Keep it short and to the point. 0.78. What is the ratio of the Amount (in $) of Ethiopia in 2006 to that in 2010?
Give a very brief answer. 0.28. What is the ratio of the Amount (in $) in Germany in 2006 to that in 2010?
Offer a very short reply. 0.92. What is the ratio of the Amount (in $) of Paraguay in 2006 to that in 2010?
Ensure brevity in your answer.  0.59. What is the ratio of the Amount (in $) of Bosnia and Herzegovina in 2007 to that in 2008?
Offer a very short reply. 0.9. What is the ratio of the Amount (in $) of Ethiopia in 2007 to that in 2008?
Offer a very short reply. 0.56. What is the ratio of the Amount (in $) of Germany in 2007 to that in 2008?
Your response must be concise. 0.98. What is the ratio of the Amount (in $) of Paraguay in 2007 to that in 2008?
Ensure brevity in your answer.  0.84. What is the ratio of the Amount (in $) of Bosnia and Herzegovina in 2007 to that in 2009?
Give a very brief answer. 0.94. What is the ratio of the Amount (in $) in Ethiopia in 2007 to that in 2009?
Your answer should be very brief. 0.45. What is the ratio of the Amount (in $) of Germany in 2007 to that in 2009?
Ensure brevity in your answer.  0.98. What is the ratio of the Amount (in $) of Paraguay in 2007 to that in 2009?
Offer a very short reply. 0.77. What is the ratio of the Amount (in $) in Bosnia and Herzegovina in 2007 to that in 2010?
Your answer should be very brief. 0.9. What is the ratio of the Amount (in $) in Ethiopia in 2007 to that in 2010?
Your answer should be very brief. 0.34. What is the ratio of the Amount (in $) of Germany in 2007 to that in 2010?
Offer a terse response. 0.96. What is the ratio of the Amount (in $) in Paraguay in 2007 to that in 2010?
Provide a short and direct response. 0.66. What is the ratio of the Amount (in $) in Bosnia and Herzegovina in 2008 to that in 2009?
Keep it short and to the point. 1.04. What is the ratio of the Amount (in $) of Ethiopia in 2008 to that in 2009?
Your answer should be compact. 0.8. What is the ratio of the Amount (in $) of Germany in 2008 to that in 2009?
Your answer should be very brief. 1. What is the ratio of the Amount (in $) of Paraguay in 2008 to that in 2009?
Make the answer very short. 0.92. What is the ratio of the Amount (in $) in Bosnia and Herzegovina in 2008 to that in 2010?
Your answer should be very brief. 0.99. What is the ratio of the Amount (in $) in Ethiopia in 2008 to that in 2010?
Offer a very short reply. 0.61. What is the ratio of the Amount (in $) in Germany in 2008 to that in 2010?
Your answer should be very brief. 0.98. What is the ratio of the Amount (in $) of Paraguay in 2008 to that in 2010?
Provide a short and direct response. 0.79. What is the ratio of the Amount (in $) of Bosnia and Herzegovina in 2009 to that in 2010?
Ensure brevity in your answer.  0.95. What is the ratio of the Amount (in $) of Ethiopia in 2009 to that in 2010?
Keep it short and to the point. 0.77. What is the ratio of the Amount (in $) of Germany in 2009 to that in 2010?
Ensure brevity in your answer.  0.98. What is the ratio of the Amount (in $) of Paraguay in 2009 to that in 2010?
Your answer should be compact. 0.86. What is the difference between the highest and the second highest Amount (in $) of Bosnia and Herzegovina?
Offer a very short reply. 6.63e+07. What is the difference between the highest and the second highest Amount (in $) of Ethiopia?
Offer a terse response. 9.75e+09. What is the difference between the highest and the second highest Amount (in $) of Germany?
Offer a terse response. 1.23e+1. What is the difference between the highest and the second highest Amount (in $) of Paraguay?
Keep it short and to the point. 2.73e+12. What is the difference between the highest and the lowest Amount (in $) of Bosnia and Herzegovina?
Make the answer very short. 3.46e+09. What is the difference between the highest and the lowest Amount (in $) of Ethiopia?
Provide a succinct answer. 2.98e+1. What is the difference between the highest and the lowest Amount (in $) in Germany?
Keep it short and to the point. 7.46e+1. What is the difference between the highest and the lowest Amount (in $) in Paraguay?
Ensure brevity in your answer.  9.31e+12. 